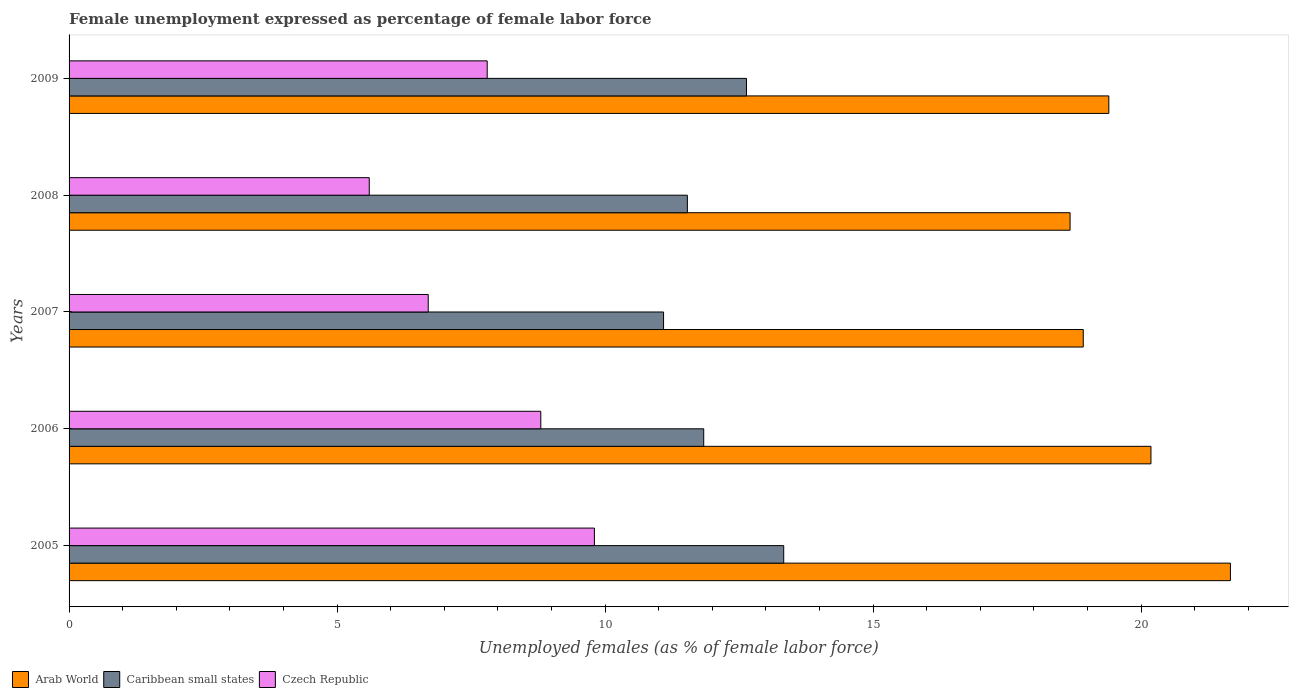How many different coloured bars are there?
Your answer should be compact. 3. Are the number of bars per tick equal to the number of legend labels?
Offer a terse response. Yes. What is the label of the 4th group of bars from the top?
Your answer should be very brief. 2006. What is the unemployment in females in in Caribbean small states in 2009?
Give a very brief answer. 12.64. Across all years, what is the maximum unemployment in females in in Arab World?
Ensure brevity in your answer.  21.66. Across all years, what is the minimum unemployment in females in in Caribbean small states?
Your response must be concise. 11.09. In which year was the unemployment in females in in Caribbean small states minimum?
Offer a very short reply. 2007. What is the total unemployment in females in in Caribbean small states in the graph?
Your answer should be compact. 60.43. What is the difference between the unemployment in females in in Czech Republic in 2006 and that in 2009?
Your answer should be compact. 1. What is the difference between the unemployment in females in in Czech Republic in 2009 and the unemployment in females in in Caribbean small states in 2007?
Give a very brief answer. -3.29. What is the average unemployment in females in in Arab World per year?
Your answer should be very brief. 19.77. In the year 2005, what is the difference between the unemployment in females in in Caribbean small states and unemployment in females in in Czech Republic?
Give a very brief answer. 3.53. What is the ratio of the unemployment in females in in Arab World in 2005 to that in 2008?
Offer a very short reply. 1.16. What is the difference between the highest and the lowest unemployment in females in in Czech Republic?
Your answer should be very brief. 4.2. In how many years, is the unemployment in females in in Caribbean small states greater than the average unemployment in females in in Caribbean small states taken over all years?
Your answer should be very brief. 2. Is the sum of the unemployment in females in in Arab World in 2005 and 2006 greater than the maximum unemployment in females in in Caribbean small states across all years?
Ensure brevity in your answer.  Yes. What does the 3rd bar from the top in 2007 represents?
Make the answer very short. Arab World. What does the 2nd bar from the bottom in 2009 represents?
Give a very brief answer. Caribbean small states. Is it the case that in every year, the sum of the unemployment in females in in Caribbean small states and unemployment in females in in Arab World is greater than the unemployment in females in in Czech Republic?
Provide a short and direct response. Yes. How many bars are there?
Your answer should be very brief. 15. Are all the bars in the graph horizontal?
Your answer should be compact. Yes. How many years are there in the graph?
Your answer should be very brief. 5. Are the values on the major ticks of X-axis written in scientific E-notation?
Make the answer very short. No. Does the graph contain any zero values?
Provide a succinct answer. No. Does the graph contain grids?
Make the answer very short. No. What is the title of the graph?
Your answer should be very brief. Female unemployment expressed as percentage of female labor force. What is the label or title of the X-axis?
Offer a very short reply. Unemployed females (as % of female labor force). What is the label or title of the Y-axis?
Offer a terse response. Years. What is the Unemployed females (as % of female labor force) of Arab World in 2005?
Your answer should be very brief. 21.66. What is the Unemployed females (as % of female labor force) of Caribbean small states in 2005?
Make the answer very short. 13.33. What is the Unemployed females (as % of female labor force) of Czech Republic in 2005?
Provide a short and direct response. 9.8. What is the Unemployed females (as % of female labor force) in Arab World in 2006?
Provide a short and direct response. 20.18. What is the Unemployed females (as % of female labor force) in Caribbean small states in 2006?
Your answer should be compact. 11.84. What is the Unemployed females (as % of female labor force) of Czech Republic in 2006?
Make the answer very short. 8.8. What is the Unemployed females (as % of female labor force) in Arab World in 2007?
Your answer should be very brief. 18.92. What is the Unemployed females (as % of female labor force) of Caribbean small states in 2007?
Provide a succinct answer. 11.09. What is the Unemployed females (as % of female labor force) in Czech Republic in 2007?
Give a very brief answer. 6.7. What is the Unemployed females (as % of female labor force) of Arab World in 2008?
Offer a terse response. 18.67. What is the Unemployed females (as % of female labor force) in Caribbean small states in 2008?
Your answer should be compact. 11.53. What is the Unemployed females (as % of female labor force) of Czech Republic in 2008?
Provide a short and direct response. 5.6. What is the Unemployed females (as % of female labor force) in Arab World in 2009?
Make the answer very short. 19.4. What is the Unemployed females (as % of female labor force) of Caribbean small states in 2009?
Provide a short and direct response. 12.64. What is the Unemployed females (as % of female labor force) in Czech Republic in 2009?
Offer a terse response. 7.8. Across all years, what is the maximum Unemployed females (as % of female labor force) of Arab World?
Provide a short and direct response. 21.66. Across all years, what is the maximum Unemployed females (as % of female labor force) in Caribbean small states?
Make the answer very short. 13.33. Across all years, what is the maximum Unemployed females (as % of female labor force) of Czech Republic?
Give a very brief answer. 9.8. Across all years, what is the minimum Unemployed females (as % of female labor force) of Arab World?
Your answer should be compact. 18.67. Across all years, what is the minimum Unemployed females (as % of female labor force) in Caribbean small states?
Make the answer very short. 11.09. Across all years, what is the minimum Unemployed females (as % of female labor force) of Czech Republic?
Provide a short and direct response. 5.6. What is the total Unemployed females (as % of female labor force) in Arab World in the graph?
Offer a terse response. 98.84. What is the total Unemployed females (as % of female labor force) in Caribbean small states in the graph?
Offer a very short reply. 60.43. What is the total Unemployed females (as % of female labor force) of Czech Republic in the graph?
Your response must be concise. 38.7. What is the difference between the Unemployed females (as % of female labor force) of Arab World in 2005 and that in 2006?
Your answer should be compact. 1.48. What is the difference between the Unemployed females (as % of female labor force) in Caribbean small states in 2005 and that in 2006?
Ensure brevity in your answer.  1.49. What is the difference between the Unemployed females (as % of female labor force) of Czech Republic in 2005 and that in 2006?
Give a very brief answer. 1. What is the difference between the Unemployed females (as % of female labor force) in Arab World in 2005 and that in 2007?
Make the answer very short. 2.75. What is the difference between the Unemployed females (as % of female labor force) of Caribbean small states in 2005 and that in 2007?
Ensure brevity in your answer.  2.24. What is the difference between the Unemployed females (as % of female labor force) in Arab World in 2005 and that in 2008?
Offer a terse response. 2.99. What is the difference between the Unemployed females (as % of female labor force) in Caribbean small states in 2005 and that in 2008?
Give a very brief answer. 1.8. What is the difference between the Unemployed females (as % of female labor force) of Czech Republic in 2005 and that in 2008?
Your response must be concise. 4.2. What is the difference between the Unemployed females (as % of female labor force) of Arab World in 2005 and that in 2009?
Offer a terse response. 2.27. What is the difference between the Unemployed females (as % of female labor force) in Caribbean small states in 2005 and that in 2009?
Make the answer very short. 0.69. What is the difference between the Unemployed females (as % of female labor force) in Czech Republic in 2005 and that in 2009?
Give a very brief answer. 2. What is the difference between the Unemployed females (as % of female labor force) of Arab World in 2006 and that in 2007?
Provide a succinct answer. 1.26. What is the difference between the Unemployed females (as % of female labor force) of Caribbean small states in 2006 and that in 2007?
Provide a short and direct response. 0.75. What is the difference between the Unemployed females (as % of female labor force) of Czech Republic in 2006 and that in 2007?
Ensure brevity in your answer.  2.1. What is the difference between the Unemployed females (as % of female labor force) of Arab World in 2006 and that in 2008?
Offer a very short reply. 1.51. What is the difference between the Unemployed females (as % of female labor force) of Caribbean small states in 2006 and that in 2008?
Give a very brief answer. 0.3. What is the difference between the Unemployed females (as % of female labor force) of Czech Republic in 2006 and that in 2008?
Your answer should be compact. 3.2. What is the difference between the Unemployed females (as % of female labor force) of Arab World in 2006 and that in 2009?
Ensure brevity in your answer.  0.79. What is the difference between the Unemployed females (as % of female labor force) in Caribbean small states in 2006 and that in 2009?
Offer a terse response. -0.8. What is the difference between the Unemployed females (as % of female labor force) in Czech Republic in 2006 and that in 2009?
Offer a terse response. 1. What is the difference between the Unemployed females (as % of female labor force) of Arab World in 2007 and that in 2008?
Make the answer very short. 0.25. What is the difference between the Unemployed females (as % of female labor force) of Caribbean small states in 2007 and that in 2008?
Give a very brief answer. -0.44. What is the difference between the Unemployed females (as % of female labor force) of Czech Republic in 2007 and that in 2008?
Your answer should be very brief. 1.1. What is the difference between the Unemployed females (as % of female labor force) of Arab World in 2007 and that in 2009?
Your answer should be very brief. -0.48. What is the difference between the Unemployed females (as % of female labor force) in Caribbean small states in 2007 and that in 2009?
Offer a terse response. -1.55. What is the difference between the Unemployed females (as % of female labor force) in Arab World in 2008 and that in 2009?
Ensure brevity in your answer.  -0.72. What is the difference between the Unemployed females (as % of female labor force) of Caribbean small states in 2008 and that in 2009?
Provide a succinct answer. -1.1. What is the difference between the Unemployed females (as % of female labor force) in Czech Republic in 2008 and that in 2009?
Your answer should be very brief. -2.2. What is the difference between the Unemployed females (as % of female labor force) in Arab World in 2005 and the Unemployed females (as % of female labor force) in Caribbean small states in 2006?
Your answer should be very brief. 9.83. What is the difference between the Unemployed females (as % of female labor force) in Arab World in 2005 and the Unemployed females (as % of female labor force) in Czech Republic in 2006?
Provide a short and direct response. 12.86. What is the difference between the Unemployed females (as % of female labor force) in Caribbean small states in 2005 and the Unemployed females (as % of female labor force) in Czech Republic in 2006?
Ensure brevity in your answer.  4.53. What is the difference between the Unemployed females (as % of female labor force) in Arab World in 2005 and the Unemployed females (as % of female labor force) in Caribbean small states in 2007?
Give a very brief answer. 10.57. What is the difference between the Unemployed females (as % of female labor force) in Arab World in 2005 and the Unemployed females (as % of female labor force) in Czech Republic in 2007?
Ensure brevity in your answer.  14.96. What is the difference between the Unemployed females (as % of female labor force) of Caribbean small states in 2005 and the Unemployed females (as % of female labor force) of Czech Republic in 2007?
Your answer should be very brief. 6.63. What is the difference between the Unemployed females (as % of female labor force) in Arab World in 2005 and the Unemployed females (as % of female labor force) in Caribbean small states in 2008?
Offer a terse response. 10.13. What is the difference between the Unemployed females (as % of female labor force) in Arab World in 2005 and the Unemployed females (as % of female labor force) in Czech Republic in 2008?
Offer a terse response. 16.06. What is the difference between the Unemployed females (as % of female labor force) of Caribbean small states in 2005 and the Unemployed females (as % of female labor force) of Czech Republic in 2008?
Ensure brevity in your answer.  7.73. What is the difference between the Unemployed females (as % of female labor force) in Arab World in 2005 and the Unemployed females (as % of female labor force) in Caribbean small states in 2009?
Make the answer very short. 9.03. What is the difference between the Unemployed females (as % of female labor force) in Arab World in 2005 and the Unemployed females (as % of female labor force) in Czech Republic in 2009?
Give a very brief answer. 13.86. What is the difference between the Unemployed females (as % of female labor force) in Caribbean small states in 2005 and the Unemployed females (as % of female labor force) in Czech Republic in 2009?
Make the answer very short. 5.53. What is the difference between the Unemployed females (as % of female labor force) of Arab World in 2006 and the Unemployed females (as % of female labor force) of Caribbean small states in 2007?
Your answer should be compact. 9.09. What is the difference between the Unemployed females (as % of female labor force) in Arab World in 2006 and the Unemployed females (as % of female labor force) in Czech Republic in 2007?
Give a very brief answer. 13.48. What is the difference between the Unemployed females (as % of female labor force) in Caribbean small states in 2006 and the Unemployed females (as % of female labor force) in Czech Republic in 2007?
Give a very brief answer. 5.14. What is the difference between the Unemployed females (as % of female labor force) of Arab World in 2006 and the Unemployed females (as % of female labor force) of Caribbean small states in 2008?
Keep it short and to the point. 8.65. What is the difference between the Unemployed females (as % of female labor force) in Arab World in 2006 and the Unemployed females (as % of female labor force) in Czech Republic in 2008?
Make the answer very short. 14.58. What is the difference between the Unemployed females (as % of female labor force) in Caribbean small states in 2006 and the Unemployed females (as % of female labor force) in Czech Republic in 2008?
Make the answer very short. 6.24. What is the difference between the Unemployed females (as % of female labor force) of Arab World in 2006 and the Unemployed females (as % of female labor force) of Caribbean small states in 2009?
Provide a succinct answer. 7.55. What is the difference between the Unemployed females (as % of female labor force) of Arab World in 2006 and the Unemployed females (as % of female labor force) of Czech Republic in 2009?
Your answer should be very brief. 12.38. What is the difference between the Unemployed females (as % of female labor force) in Caribbean small states in 2006 and the Unemployed females (as % of female labor force) in Czech Republic in 2009?
Your response must be concise. 4.04. What is the difference between the Unemployed females (as % of female labor force) of Arab World in 2007 and the Unemployed females (as % of female labor force) of Caribbean small states in 2008?
Provide a succinct answer. 7.38. What is the difference between the Unemployed females (as % of female labor force) of Arab World in 2007 and the Unemployed females (as % of female labor force) of Czech Republic in 2008?
Give a very brief answer. 13.32. What is the difference between the Unemployed females (as % of female labor force) of Caribbean small states in 2007 and the Unemployed females (as % of female labor force) of Czech Republic in 2008?
Your response must be concise. 5.49. What is the difference between the Unemployed females (as % of female labor force) in Arab World in 2007 and the Unemployed females (as % of female labor force) in Caribbean small states in 2009?
Your response must be concise. 6.28. What is the difference between the Unemployed females (as % of female labor force) in Arab World in 2007 and the Unemployed females (as % of female labor force) in Czech Republic in 2009?
Your answer should be compact. 11.12. What is the difference between the Unemployed females (as % of female labor force) of Caribbean small states in 2007 and the Unemployed females (as % of female labor force) of Czech Republic in 2009?
Ensure brevity in your answer.  3.29. What is the difference between the Unemployed females (as % of female labor force) in Arab World in 2008 and the Unemployed females (as % of female labor force) in Caribbean small states in 2009?
Your answer should be compact. 6.04. What is the difference between the Unemployed females (as % of female labor force) of Arab World in 2008 and the Unemployed females (as % of female labor force) of Czech Republic in 2009?
Your answer should be compact. 10.87. What is the difference between the Unemployed females (as % of female labor force) in Caribbean small states in 2008 and the Unemployed females (as % of female labor force) in Czech Republic in 2009?
Offer a terse response. 3.73. What is the average Unemployed females (as % of female labor force) in Arab World per year?
Provide a short and direct response. 19.77. What is the average Unemployed females (as % of female labor force) of Caribbean small states per year?
Offer a very short reply. 12.09. What is the average Unemployed females (as % of female labor force) of Czech Republic per year?
Give a very brief answer. 7.74. In the year 2005, what is the difference between the Unemployed females (as % of female labor force) in Arab World and Unemployed females (as % of female labor force) in Caribbean small states?
Your answer should be very brief. 8.33. In the year 2005, what is the difference between the Unemployed females (as % of female labor force) of Arab World and Unemployed females (as % of female labor force) of Czech Republic?
Offer a terse response. 11.86. In the year 2005, what is the difference between the Unemployed females (as % of female labor force) of Caribbean small states and Unemployed females (as % of female labor force) of Czech Republic?
Make the answer very short. 3.53. In the year 2006, what is the difference between the Unemployed females (as % of female labor force) in Arab World and Unemployed females (as % of female labor force) in Caribbean small states?
Ensure brevity in your answer.  8.34. In the year 2006, what is the difference between the Unemployed females (as % of female labor force) of Arab World and Unemployed females (as % of female labor force) of Czech Republic?
Keep it short and to the point. 11.38. In the year 2006, what is the difference between the Unemployed females (as % of female labor force) in Caribbean small states and Unemployed females (as % of female labor force) in Czech Republic?
Offer a very short reply. 3.04. In the year 2007, what is the difference between the Unemployed females (as % of female labor force) of Arab World and Unemployed females (as % of female labor force) of Caribbean small states?
Make the answer very short. 7.83. In the year 2007, what is the difference between the Unemployed females (as % of female labor force) of Arab World and Unemployed females (as % of female labor force) of Czech Republic?
Offer a very short reply. 12.22. In the year 2007, what is the difference between the Unemployed females (as % of female labor force) of Caribbean small states and Unemployed females (as % of female labor force) of Czech Republic?
Give a very brief answer. 4.39. In the year 2008, what is the difference between the Unemployed females (as % of female labor force) in Arab World and Unemployed females (as % of female labor force) in Caribbean small states?
Ensure brevity in your answer.  7.14. In the year 2008, what is the difference between the Unemployed females (as % of female labor force) of Arab World and Unemployed females (as % of female labor force) of Czech Republic?
Give a very brief answer. 13.07. In the year 2008, what is the difference between the Unemployed females (as % of female labor force) in Caribbean small states and Unemployed females (as % of female labor force) in Czech Republic?
Make the answer very short. 5.93. In the year 2009, what is the difference between the Unemployed females (as % of female labor force) in Arab World and Unemployed females (as % of female labor force) in Caribbean small states?
Your response must be concise. 6.76. In the year 2009, what is the difference between the Unemployed females (as % of female labor force) in Arab World and Unemployed females (as % of female labor force) in Czech Republic?
Make the answer very short. 11.6. In the year 2009, what is the difference between the Unemployed females (as % of female labor force) of Caribbean small states and Unemployed females (as % of female labor force) of Czech Republic?
Provide a short and direct response. 4.84. What is the ratio of the Unemployed females (as % of female labor force) of Arab World in 2005 to that in 2006?
Make the answer very short. 1.07. What is the ratio of the Unemployed females (as % of female labor force) in Caribbean small states in 2005 to that in 2006?
Offer a very short reply. 1.13. What is the ratio of the Unemployed females (as % of female labor force) of Czech Republic in 2005 to that in 2006?
Give a very brief answer. 1.11. What is the ratio of the Unemployed females (as % of female labor force) of Arab World in 2005 to that in 2007?
Your response must be concise. 1.15. What is the ratio of the Unemployed females (as % of female labor force) of Caribbean small states in 2005 to that in 2007?
Give a very brief answer. 1.2. What is the ratio of the Unemployed females (as % of female labor force) of Czech Republic in 2005 to that in 2007?
Offer a terse response. 1.46. What is the ratio of the Unemployed females (as % of female labor force) of Arab World in 2005 to that in 2008?
Provide a short and direct response. 1.16. What is the ratio of the Unemployed females (as % of female labor force) of Caribbean small states in 2005 to that in 2008?
Your answer should be compact. 1.16. What is the ratio of the Unemployed females (as % of female labor force) in Czech Republic in 2005 to that in 2008?
Your response must be concise. 1.75. What is the ratio of the Unemployed females (as % of female labor force) in Arab World in 2005 to that in 2009?
Provide a succinct answer. 1.12. What is the ratio of the Unemployed females (as % of female labor force) in Caribbean small states in 2005 to that in 2009?
Provide a succinct answer. 1.05. What is the ratio of the Unemployed females (as % of female labor force) of Czech Republic in 2005 to that in 2009?
Offer a very short reply. 1.26. What is the ratio of the Unemployed females (as % of female labor force) in Arab World in 2006 to that in 2007?
Your response must be concise. 1.07. What is the ratio of the Unemployed females (as % of female labor force) in Caribbean small states in 2006 to that in 2007?
Ensure brevity in your answer.  1.07. What is the ratio of the Unemployed females (as % of female labor force) in Czech Republic in 2006 to that in 2007?
Your answer should be very brief. 1.31. What is the ratio of the Unemployed females (as % of female labor force) of Arab World in 2006 to that in 2008?
Provide a short and direct response. 1.08. What is the ratio of the Unemployed females (as % of female labor force) of Caribbean small states in 2006 to that in 2008?
Your answer should be compact. 1.03. What is the ratio of the Unemployed females (as % of female labor force) of Czech Republic in 2006 to that in 2008?
Offer a terse response. 1.57. What is the ratio of the Unemployed females (as % of female labor force) in Arab World in 2006 to that in 2009?
Your answer should be compact. 1.04. What is the ratio of the Unemployed females (as % of female labor force) in Caribbean small states in 2006 to that in 2009?
Your response must be concise. 0.94. What is the ratio of the Unemployed females (as % of female labor force) of Czech Republic in 2006 to that in 2009?
Ensure brevity in your answer.  1.13. What is the ratio of the Unemployed females (as % of female labor force) in Arab World in 2007 to that in 2008?
Provide a succinct answer. 1.01. What is the ratio of the Unemployed females (as % of female labor force) of Caribbean small states in 2007 to that in 2008?
Your response must be concise. 0.96. What is the ratio of the Unemployed females (as % of female labor force) in Czech Republic in 2007 to that in 2008?
Keep it short and to the point. 1.2. What is the ratio of the Unemployed females (as % of female labor force) of Arab World in 2007 to that in 2009?
Ensure brevity in your answer.  0.98. What is the ratio of the Unemployed females (as % of female labor force) of Caribbean small states in 2007 to that in 2009?
Make the answer very short. 0.88. What is the ratio of the Unemployed females (as % of female labor force) of Czech Republic in 2007 to that in 2009?
Provide a succinct answer. 0.86. What is the ratio of the Unemployed females (as % of female labor force) of Arab World in 2008 to that in 2009?
Give a very brief answer. 0.96. What is the ratio of the Unemployed females (as % of female labor force) in Caribbean small states in 2008 to that in 2009?
Offer a very short reply. 0.91. What is the ratio of the Unemployed females (as % of female labor force) of Czech Republic in 2008 to that in 2009?
Offer a terse response. 0.72. What is the difference between the highest and the second highest Unemployed females (as % of female labor force) of Arab World?
Make the answer very short. 1.48. What is the difference between the highest and the second highest Unemployed females (as % of female labor force) in Caribbean small states?
Offer a very short reply. 0.69. What is the difference between the highest and the lowest Unemployed females (as % of female labor force) of Arab World?
Your answer should be compact. 2.99. What is the difference between the highest and the lowest Unemployed females (as % of female labor force) of Caribbean small states?
Provide a short and direct response. 2.24. 